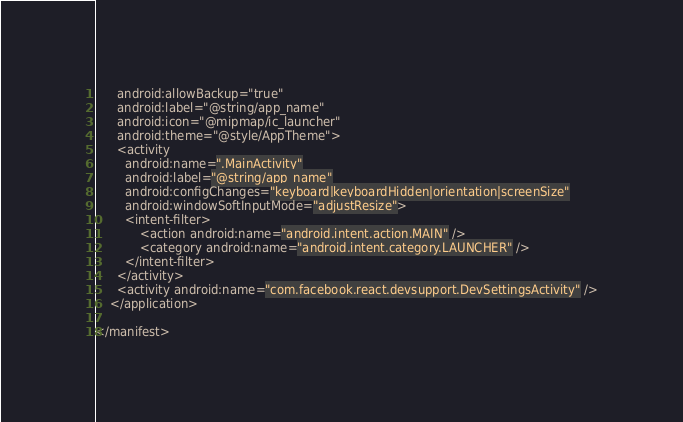<code> <loc_0><loc_0><loc_500><loc_500><_XML_>      android:allowBackup="true"
      android:label="@string/app_name"
      android:icon="@mipmap/ic_launcher"
      android:theme="@style/AppTheme">
      <activity
        android:name=".MainActivity"
        android:label="@string/app_name"
        android:configChanges="keyboard|keyboardHidden|orientation|screenSize"
        android:windowSoftInputMode="adjustResize">
        <intent-filter>
            <action android:name="android.intent.action.MAIN" />
            <category android:name="android.intent.category.LAUNCHER" />
        </intent-filter>
      </activity>
      <activity android:name="com.facebook.react.devsupport.DevSettingsActivity" />
    </application>

</manifest>
</code> 